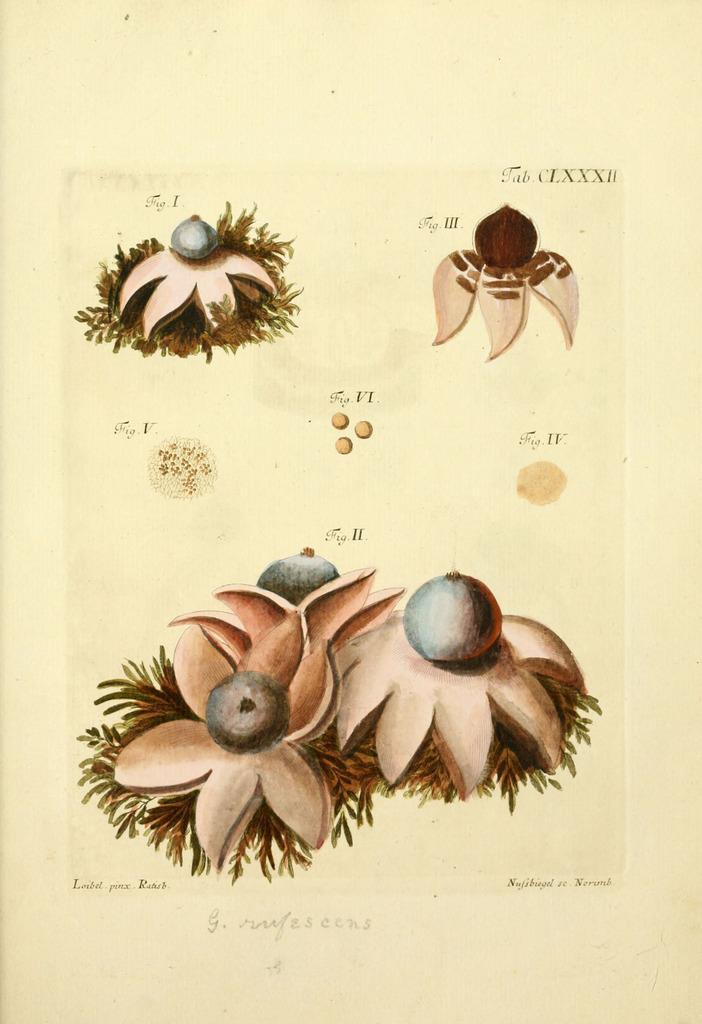In one or two sentences, can you explain what this image depicts? In this picture there is a yellow paper in the front with some drawing flowers. 